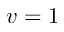Convert formula to latex. <formula><loc_0><loc_0><loc_500><loc_500>v = 1</formula> 